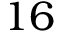Convert formula to latex. <formula><loc_0><loc_0><loc_500><loc_500>1 6</formula> 